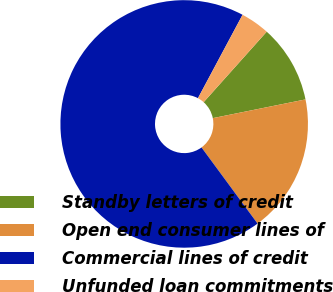Convert chart to OTSL. <chart><loc_0><loc_0><loc_500><loc_500><pie_chart><fcel>Standby letters of credit<fcel>Open end consumer lines of<fcel>Commercial lines of credit<fcel>Unfunded loan commitments<nl><fcel>10.21%<fcel>18.07%<fcel>67.91%<fcel>3.8%<nl></chart> 